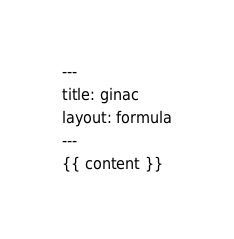Convert code to text. <code><loc_0><loc_0><loc_500><loc_500><_HTML_>---
title: ginac
layout: formula
---
{{ content }}
</code> 